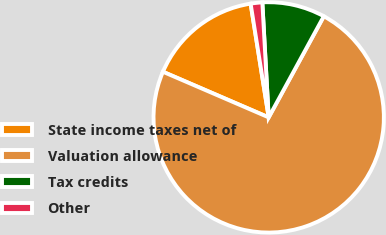Convert chart. <chart><loc_0><loc_0><loc_500><loc_500><pie_chart><fcel>State income taxes net of<fcel>Valuation allowance<fcel>Tax credits<fcel>Other<nl><fcel>16.01%<fcel>73.54%<fcel>8.82%<fcel>1.63%<nl></chart> 